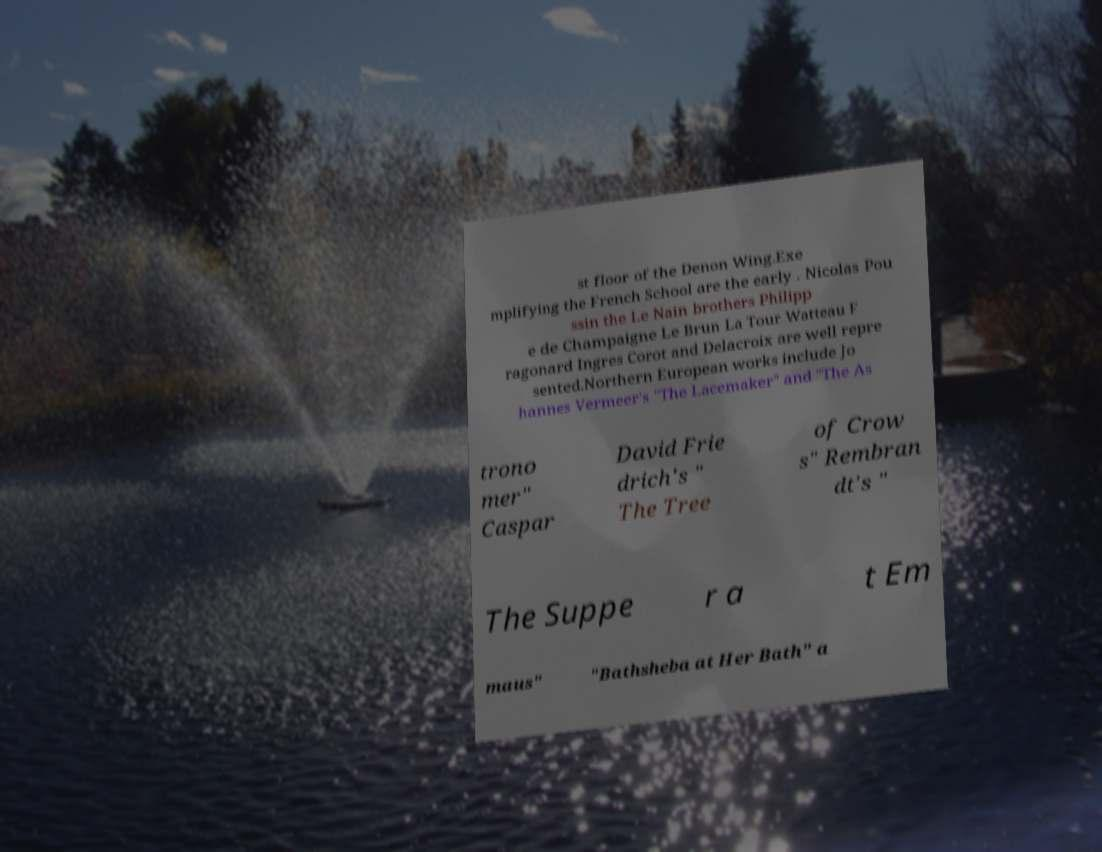Could you assist in decoding the text presented in this image and type it out clearly? st floor of the Denon Wing.Exe mplifying the French School are the early . Nicolas Pou ssin the Le Nain brothers Philipp e de Champaigne Le Brun La Tour Watteau F ragonard Ingres Corot and Delacroix are well repre sented.Northern European works include Jo hannes Vermeer's "The Lacemaker" and "The As trono mer" Caspar David Frie drich's " The Tree of Crow s" Rembran dt's " The Suppe r a t Em maus" "Bathsheba at Her Bath" a 